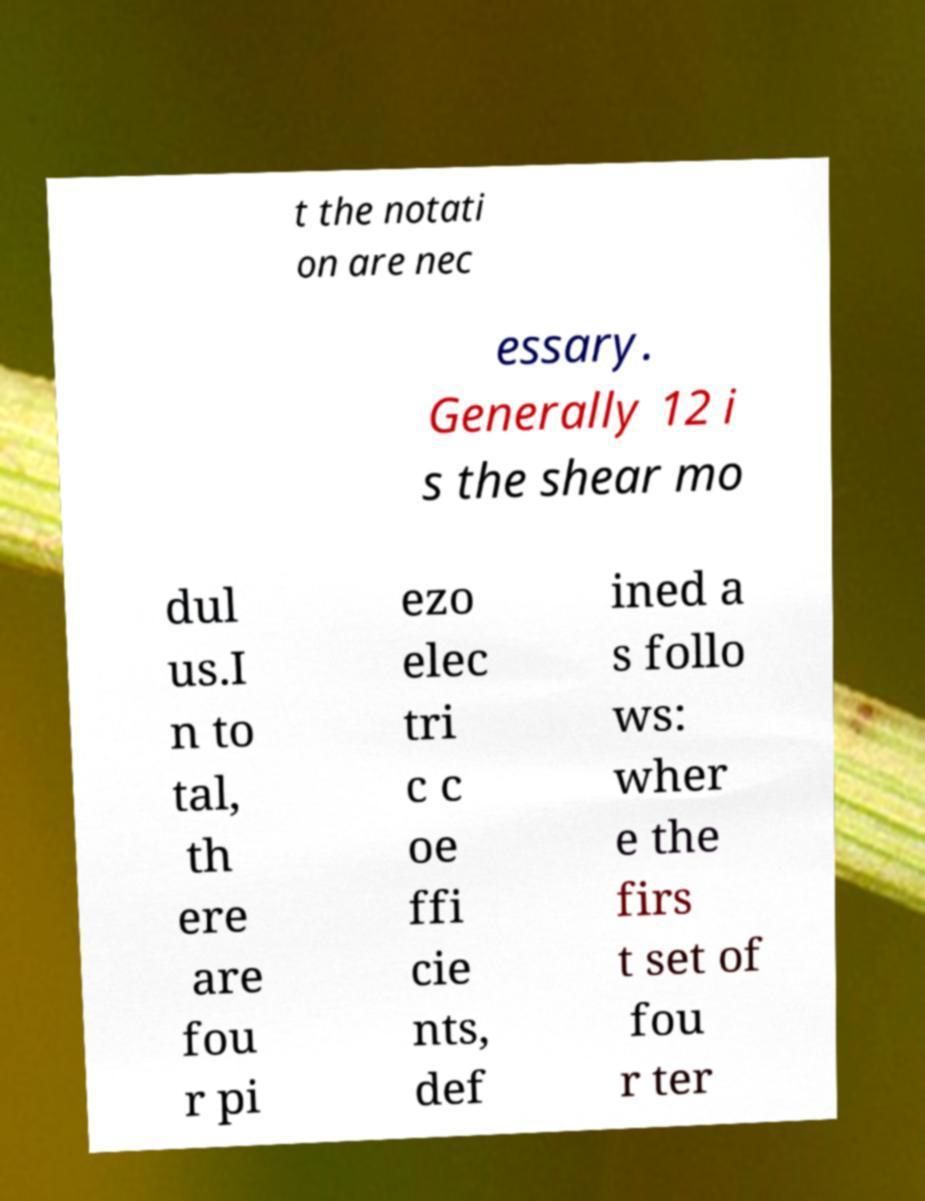Can you accurately transcribe the text from the provided image for me? t the notati on are nec essary. Generally 12 i s the shear mo dul us.I n to tal, th ere are fou r pi ezo elec tri c c oe ffi cie nts, def ined a s follo ws: wher e the firs t set of fou r ter 